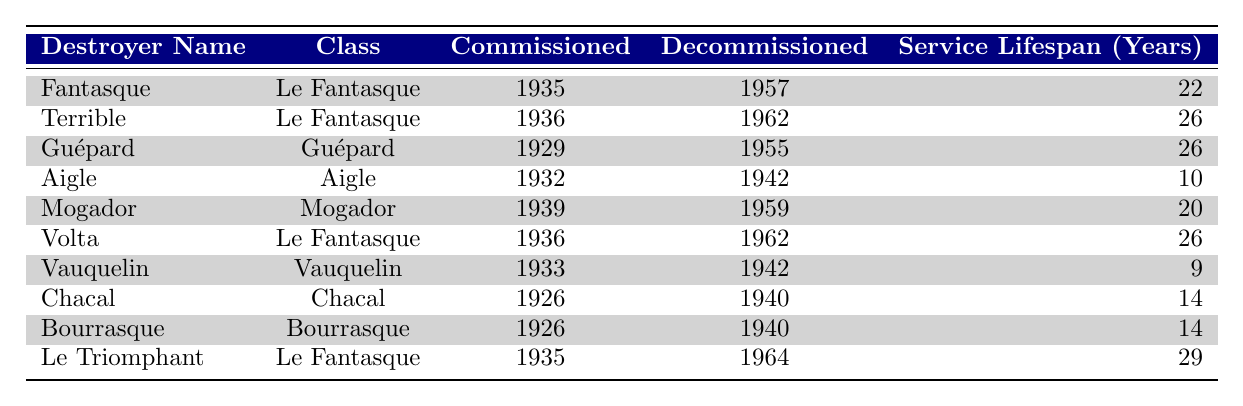What is the service lifespan of the destroyer "Le Triomphant"? The table indicates that "Le Triomphant" was commissioned in 1935 and decommissioned in 1964. To find the service lifespan, subtract the commissioned year from the decommissioned year: 1964 - 1935 = 29 years.
Answer: 29 years Which destroyer had the shortest service lifespan? Looking at the table, "Vauquelin" was commissioned in 1933 and decommissioned in 1942, leading to a service lifespan of 9 years, which is less than all others listed.
Answer: Vauquelin How many destroyers had a service lifespan of 26 years? The table shows two destroyers, "Terrible" and "Volta," each with a service lifespan of 26 years.
Answer: 2 What is the average service lifespan of the destroyers listed in the table? To calculate the average, first sum the service lifespans: 22 + 26 + 26 + 10 + 20 + 26 + 9 + 14 + 14 + 29 =  14 years. There are 10 destroyers, so the average is  14 years / 10 = 19.9 years.
Answer: 19.9 years Did any destroyer serve for more than 25 years? Using the table, "Terrible," "Guépard," "Volta," and "Le Triomphant" each served for 26 years or more, confirming that there were destroyers with over 25 years of service lifespan.
Answer: Yes Which class of destroyers had the most vessels listed? The "Le Fantasque" class is noted with three destroyers: "Fantasque," "Terrible," and "Volta," making it the class with the most vessels in the table.
Answer: Le Fantasque What is the difference in years of service between the destroyers "Mogador" and "Aigle"? "Mogador" served for 20 years (1939 to 1959) while "Aigle" had 10 years (1932 to 1942). The difference in their service spans is calculated as 20 - 10 = 10 years.
Answer: 10 years How many destroyers were decommissioned before 1950? According to the table, the destroyers "Aigle," "Vauquelin," "Chacal," and "Bourrasque" were decommissioned before 1950, totaling four destroyers.
Answer: 4 Which destroyer class had the longest single service lifespan? Examining the table, "Le Triomphant" served for the longest duration of 29 years, which belongs to the "Le Fantasque" class.
Answer: Le Fantasque Are there any destroyers with the same commissioning year? The table shows that "Terrible" and "Volta" were both commissioned in 1936, indicating there are destroyers with the same commissioning year.
Answer: Yes 